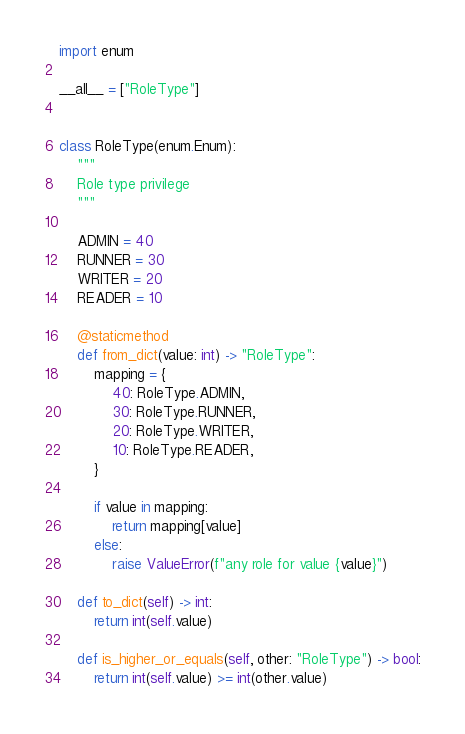Convert code to text. <code><loc_0><loc_0><loc_500><loc_500><_Python_>import enum

__all__ = ["RoleType"]


class RoleType(enum.Enum):
    """
    Role type privilege
    """

    ADMIN = 40
    RUNNER = 30
    WRITER = 20
    READER = 10

    @staticmethod
    def from_dict(value: int) -> "RoleType":
        mapping = {
            40: RoleType.ADMIN,
            30: RoleType.RUNNER,
            20: RoleType.WRITER,
            10: RoleType.READER,
        }

        if value in mapping:
            return mapping[value]
        else:
            raise ValueError(f"any role for value {value}")

    def to_dict(self) -> int:
        return int(self.value)

    def is_higher_or_equals(self, other: "RoleType") -> bool:
        return int(self.value) >= int(other.value)
</code> 